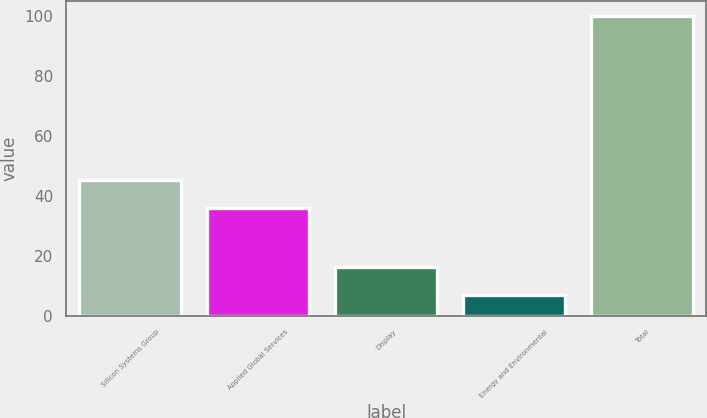<chart> <loc_0><loc_0><loc_500><loc_500><bar_chart><fcel>Silicon Systems Group<fcel>Applied Global Services<fcel>Display<fcel>Energy and Environmental<fcel>Total<nl><fcel>45.3<fcel>36<fcel>16.3<fcel>7<fcel>100<nl></chart> 